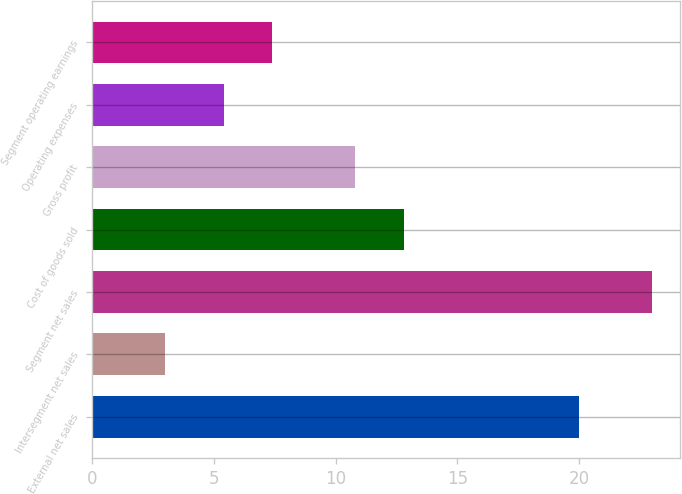Convert chart. <chart><loc_0><loc_0><loc_500><loc_500><bar_chart><fcel>External net sales<fcel>Intersegment net sales<fcel>Segment net sales<fcel>Cost of goods sold<fcel>Gross profit<fcel>Operating expenses<fcel>Segment operating earnings<nl><fcel>20<fcel>3<fcel>23<fcel>12.8<fcel>10.8<fcel>5.4<fcel>7.4<nl></chart> 